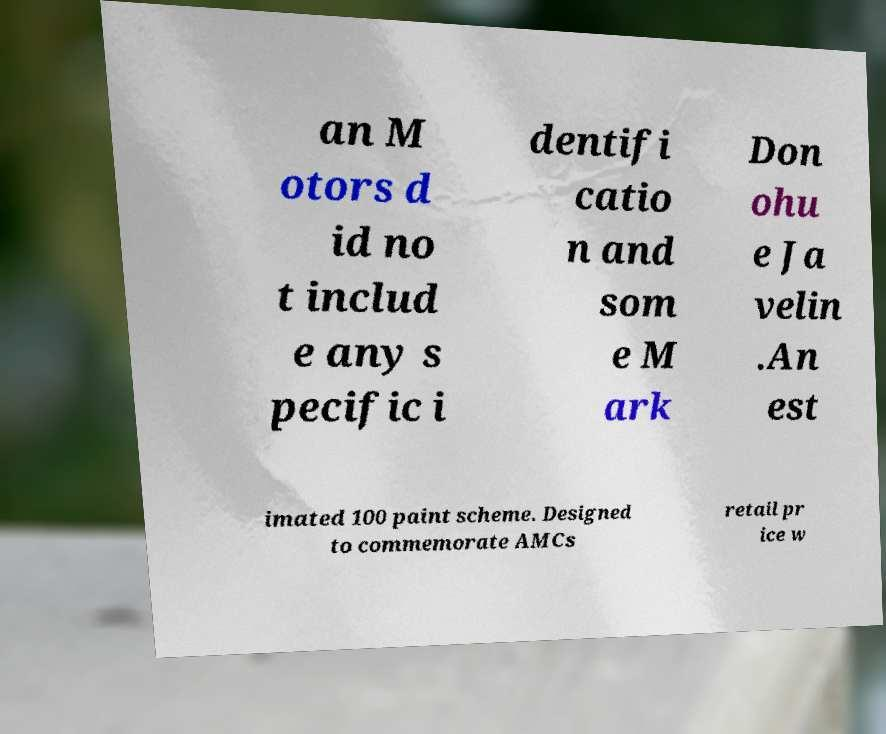Please identify and transcribe the text found in this image. an M otors d id no t includ e any s pecific i dentifi catio n and som e M ark Don ohu e Ja velin .An est imated 100 paint scheme. Designed to commemorate AMCs retail pr ice w 